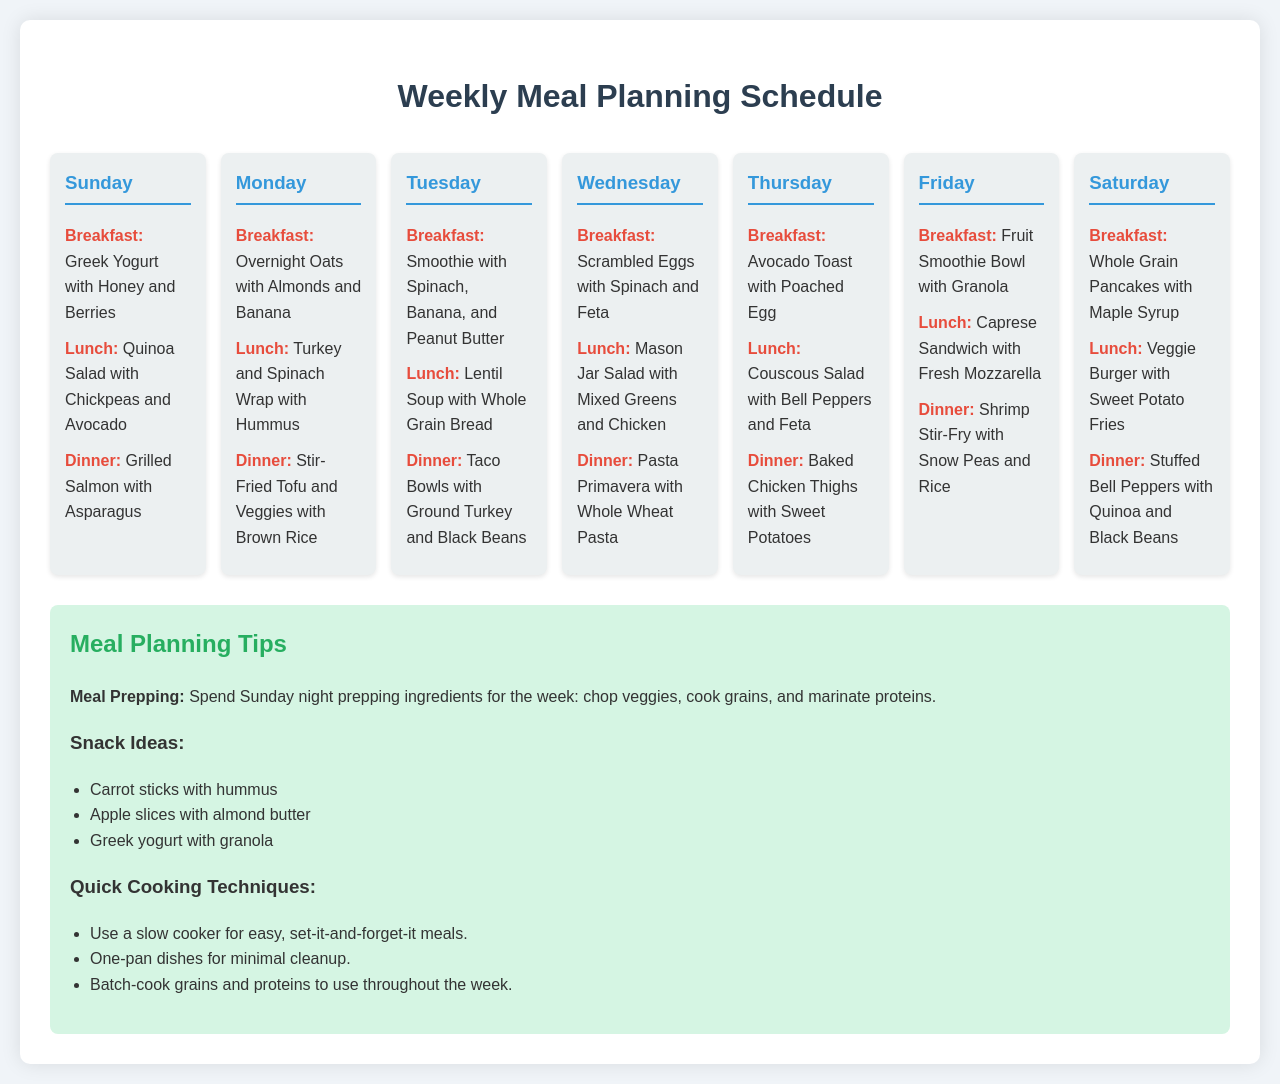what is the breakfast on Sunday? The breakfast listed for Sunday is Greek Yogurt with Honey and Berries.
Answer: Greek Yogurt with Honey and Berries what is the lunch for Tuesday? The lunch for Tuesday is Lentil Soup with Whole Grain Bread.
Answer: Lentil Soup with Whole Grain Bread which day features Baked Chicken Thighs for dinner? Baked Chicken Thighs is the dinner option on Thursday.
Answer: Thursday how many different types of grains are mentioned in the meals? The types of grains mentioned are quinoa, brown rice, whole grain, and whole wheat pasta, totaling four types.
Answer: 4 what snack ideas are mentioned? Snack ideas from the document include carrot sticks with hummus, apple slices with almond butter, and Greek yogurt with granola.
Answer: Carrot sticks with hummus, apple slices with almond butter, Greek yogurt with granola what is the cooking technique recommended for easy meals? The recommended cooking technique for easy meals is using a slow cooker.
Answer: Slow cooker how many meal options are provided for dinner throughout the week? There are a total of seven dinner options provided, one for each day of the week.
Answer: 7 what color is the background of the document? The background color of the document is a light blue-gray.
Answer: Light blue-gray what is the purpose of the tips section? The tips section provides suggestions for meal planning and preparation, along with snack ideas and quick cooking techniques.
Answer: Suggestions for meal planning and preparation 